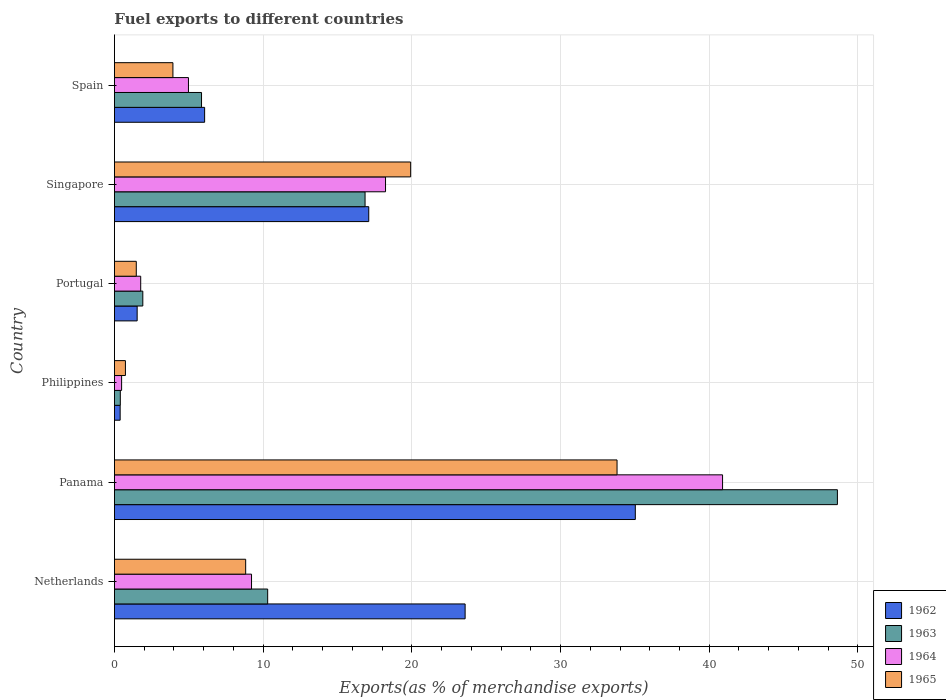How many different coloured bars are there?
Your response must be concise. 4. How many groups of bars are there?
Provide a short and direct response. 6. Are the number of bars on each tick of the Y-axis equal?
Your answer should be compact. Yes. How many bars are there on the 5th tick from the top?
Make the answer very short. 4. How many bars are there on the 4th tick from the bottom?
Ensure brevity in your answer.  4. In how many cases, is the number of bars for a given country not equal to the number of legend labels?
Offer a very short reply. 0. What is the percentage of exports to different countries in 1962 in Singapore?
Your answer should be compact. 17.1. Across all countries, what is the maximum percentage of exports to different countries in 1964?
Keep it short and to the point. 40.9. Across all countries, what is the minimum percentage of exports to different countries in 1963?
Provide a succinct answer. 0.4. In which country was the percentage of exports to different countries in 1964 maximum?
Your response must be concise. Panama. What is the total percentage of exports to different countries in 1964 in the graph?
Ensure brevity in your answer.  75.58. What is the difference between the percentage of exports to different countries in 1965 in Netherlands and that in Spain?
Your answer should be very brief. 4.89. What is the difference between the percentage of exports to different countries in 1965 in Portugal and the percentage of exports to different countries in 1963 in Philippines?
Provide a short and direct response. 1.07. What is the average percentage of exports to different countries in 1965 per country?
Offer a very short reply. 11.45. What is the difference between the percentage of exports to different countries in 1964 and percentage of exports to different countries in 1965 in Spain?
Provide a short and direct response. 1.04. In how many countries, is the percentage of exports to different countries in 1963 greater than 20 %?
Offer a very short reply. 1. What is the ratio of the percentage of exports to different countries in 1965 in Netherlands to that in Spain?
Ensure brevity in your answer.  2.24. Is the percentage of exports to different countries in 1962 in Panama less than that in Portugal?
Provide a succinct answer. No. What is the difference between the highest and the second highest percentage of exports to different countries in 1962?
Give a very brief answer. 11.45. What is the difference between the highest and the lowest percentage of exports to different countries in 1962?
Give a very brief answer. 34.64. In how many countries, is the percentage of exports to different countries in 1964 greater than the average percentage of exports to different countries in 1964 taken over all countries?
Provide a short and direct response. 2. Is the sum of the percentage of exports to different countries in 1965 in Panama and Singapore greater than the maximum percentage of exports to different countries in 1962 across all countries?
Keep it short and to the point. Yes. Is it the case that in every country, the sum of the percentage of exports to different countries in 1962 and percentage of exports to different countries in 1964 is greater than the sum of percentage of exports to different countries in 1965 and percentage of exports to different countries in 1963?
Ensure brevity in your answer.  No. What does the 1st bar from the top in Panama represents?
Keep it short and to the point. 1965. What does the 3rd bar from the bottom in Spain represents?
Provide a short and direct response. 1964. How many bars are there?
Your answer should be compact. 24. How many countries are there in the graph?
Keep it short and to the point. 6. Does the graph contain any zero values?
Keep it short and to the point. No. Does the graph contain grids?
Keep it short and to the point. Yes. Where does the legend appear in the graph?
Offer a terse response. Bottom right. How many legend labels are there?
Keep it short and to the point. 4. What is the title of the graph?
Give a very brief answer. Fuel exports to different countries. What is the label or title of the X-axis?
Offer a very short reply. Exports(as % of merchandise exports). What is the Exports(as % of merchandise exports) of 1962 in Netherlands?
Make the answer very short. 23.58. What is the Exports(as % of merchandise exports) of 1963 in Netherlands?
Ensure brevity in your answer.  10.31. What is the Exports(as % of merchandise exports) in 1964 in Netherlands?
Your answer should be very brief. 9.22. What is the Exports(as % of merchandise exports) in 1965 in Netherlands?
Offer a terse response. 8.83. What is the Exports(as % of merchandise exports) in 1962 in Panama?
Ensure brevity in your answer.  35.03. What is the Exports(as % of merchandise exports) in 1963 in Panama?
Your answer should be very brief. 48.62. What is the Exports(as % of merchandise exports) in 1964 in Panama?
Offer a terse response. 40.9. What is the Exports(as % of merchandise exports) of 1965 in Panama?
Make the answer very short. 33.8. What is the Exports(as % of merchandise exports) of 1962 in Philippines?
Provide a short and direct response. 0.38. What is the Exports(as % of merchandise exports) in 1963 in Philippines?
Your response must be concise. 0.4. What is the Exports(as % of merchandise exports) of 1964 in Philippines?
Keep it short and to the point. 0.48. What is the Exports(as % of merchandise exports) of 1965 in Philippines?
Give a very brief answer. 0.74. What is the Exports(as % of merchandise exports) of 1962 in Portugal?
Ensure brevity in your answer.  1.53. What is the Exports(as % of merchandise exports) of 1963 in Portugal?
Ensure brevity in your answer.  1.91. What is the Exports(as % of merchandise exports) in 1964 in Portugal?
Keep it short and to the point. 1.77. What is the Exports(as % of merchandise exports) in 1965 in Portugal?
Offer a terse response. 1.47. What is the Exports(as % of merchandise exports) in 1962 in Singapore?
Your answer should be compact. 17.1. What is the Exports(as % of merchandise exports) of 1963 in Singapore?
Provide a short and direct response. 16.85. What is the Exports(as % of merchandise exports) of 1964 in Singapore?
Make the answer very short. 18.23. What is the Exports(as % of merchandise exports) of 1965 in Singapore?
Your response must be concise. 19.92. What is the Exports(as % of merchandise exports) of 1962 in Spain?
Your response must be concise. 6.07. What is the Exports(as % of merchandise exports) in 1963 in Spain?
Your response must be concise. 5.86. What is the Exports(as % of merchandise exports) of 1964 in Spain?
Ensure brevity in your answer.  4.98. What is the Exports(as % of merchandise exports) in 1965 in Spain?
Make the answer very short. 3.93. Across all countries, what is the maximum Exports(as % of merchandise exports) in 1962?
Keep it short and to the point. 35.03. Across all countries, what is the maximum Exports(as % of merchandise exports) in 1963?
Provide a succinct answer. 48.62. Across all countries, what is the maximum Exports(as % of merchandise exports) of 1964?
Your answer should be very brief. 40.9. Across all countries, what is the maximum Exports(as % of merchandise exports) of 1965?
Provide a succinct answer. 33.8. Across all countries, what is the minimum Exports(as % of merchandise exports) of 1962?
Make the answer very short. 0.38. Across all countries, what is the minimum Exports(as % of merchandise exports) of 1963?
Ensure brevity in your answer.  0.4. Across all countries, what is the minimum Exports(as % of merchandise exports) of 1964?
Offer a terse response. 0.48. Across all countries, what is the minimum Exports(as % of merchandise exports) of 1965?
Your response must be concise. 0.74. What is the total Exports(as % of merchandise exports) in 1962 in the graph?
Offer a terse response. 83.7. What is the total Exports(as % of merchandise exports) in 1963 in the graph?
Ensure brevity in your answer.  83.94. What is the total Exports(as % of merchandise exports) in 1964 in the graph?
Your answer should be compact. 75.58. What is the total Exports(as % of merchandise exports) of 1965 in the graph?
Your answer should be very brief. 68.69. What is the difference between the Exports(as % of merchandise exports) in 1962 in Netherlands and that in Panama?
Offer a very short reply. -11.45. What is the difference between the Exports(as % of merchandise exports) in 1963 in Netherlands and that in Panama?
Ensure brevity in your answer.  -38.32. What is the difference between the Exports(as % of merchandise exports) of 1964 in Netherlands and that in Panama?
Ensure brevity in your answer.  -31.68. What is the difference between the Exports(as % of merchandise exports) in 1965 in Netherlands and that in Panama?
Provide a succinct answer. -24.98. What is the difference between the Exports(as % of merchandise exports) of 1962 in Netherlands and that in Philippines?
Keep it short and to the point. 23.2. What is the difference between the Exports(as % of merchandise exports) in 1963 in Netherlands and that in Philippines?
Make the answer very short. 9.91. What is the difference between the Exports(as % of merchandise exports) of 1964 in Netherlands and that in Philippines?
Your answer should be very brief. 8.74. What is the difference between the Exports(as % of merchandise exports) of 1965 in Netherlands and that in Philippines?
Your answer should be compact. 8.09. What is the difference between the Exports(as % of merchandise exports) in 1962 in Netherlands and that in Portugal?
Your answer should be very brief. 22.06. What is the difference between the Exports(as % of merchandise exports) in 1963 in Netherlands and that in Portugal?
Offer a very short reply. 8.4. What is the difference between the Exports(as % of merchandise exports) in 1964 in Netherlands and that in Portugal?
Your answer should be very brief. 7.45. What is the difference between the Exports(as % of merchandise exports) in 1965 in Netherlands and that in Portugal?
Provide a short and direct response. 7.36. What is the difference between the Exports(as % of merchandise exports) in 1962 in Netherlands and that in Singapore?
Keep it short and to the point. 6.48. What is the difference between the Exports(as % of merchandise exports) of 1963 in Netherlands and that in Singapore?
Offer a very short reply. -6.55. What is the difference between the Exports(as % of merchandise exports) in 1964 in Netherlands and that in Singapore?
Your answer should be compact. -9.01. What is the difference between the Exports(as % of merchandise exports) in 1965 in Netherlands and that in Singapore?
Give a very brief answer. -11.1. What is the difference between the Exports(as % of merchandise exports) of 1962 in Netherlands and that in Spain?
Offer a very short reply. 17.52. What is the difference between the Exports(as % of merchandise exports) in 1963 in Netherlands and that in Spain?
Provide a short and direct response. 4.45. What is the difference between the Exports(as % of merchandise exports) in 1964 in Netherlands and that in Spain?
Your answer should be very brief. 4.24. What is the difference between the Exports(as % of merchandise exports) of 1965 in Netherlands and that in Spain?
Offer a terse response. 4.89. What is the difference between the Exports(as % of merchandise exports) of 1962 in Panama and that in Philippines?
Provide a short and direct response. 34.65. What is the difference between the Exports(as % of merchandise exports) of 1963 in Panama and that in Philippines?
Make the answer very short. 48.22. What is the difference between the Exports(as % of merchandise exports) of 1964 in Panama and that in Philippines?
Offer a terse response. 40.41. What is the difference between the Exports(as % of merchandise exports) of 1965 in Panama and that in Philippines?
Your response must be concise. 33.06. What is the difference between the Exports(as % of merchandise exports) in 1962 in Panama and that in Portugal?
Offer a terse response. 33.5. What is the difference between the Exports(as % of merchandise exports) in 1963 in Panama and that in Portugal?
Keep it short and to the point. 46.71. What is the difference between the Exports(as % of merchandise exports) in 1964 in Panama and that in Portugal?
Make the answer very short. 39.13. What is the difference between the Exports(as % of merchandise exports) in 1965 in Panama and that in Portugal?
Offer a terse response. 32.33. What is the difference between the Exports(as % of merchandise exports) in 1962 in Panama and that in Singapore?
Your answer should be compact. 17.93. What is the difference between the Exports(as % of merchandise exports) of 1963 in Panama and that in Singapore?
Keep it short and to the point. 31.77. What is the difference between the Exports(as % of merchandise exports) of 1964 in Panama and that in Singapore?
Give a very brief answer. 22.67. What is the difference between the Exports(as % of merchandise exports) of 1965 in Panama and that in Singapore?
Give a very brief answer. 13.88. What is the difference between the Exports(as % of merchandise exports) of 1962 in Panama and that in Spain?
Ensure brevity in your answer.  28.96. What is the difference between the Exports(as % of merchandise exports) in 1963 in Panama and that in Spain?
Provide a short and direct response. 42.76. What is the difference between the Exports(as % of merchandise exports) of 1964 in Panama and that in Spain?
Make the answer very short. 35.92. What is the difference between the Exports(as % of merchandise exports) of 1965 in Panama and that in Spain?
Give a very brief answer. 29.87. What is the difference between the Exports(as % of merchandise exports) in 1962 in Philippines and that in Portugal?
Your answer should be compact. -1.14. What is the difference between the Exports(as % of merchandise exports) in 1963 in Philippines and that in Portugal?
Make the answer very short. -1.51. What is the difference between the Exports(as % of merchandise exports) in 1964 in Philippines and that in Portugal?
Keep it short and to the point. -1.28. What is the difference between the Exports(as % of merchandise exports) of 1965 in Philippines and that in Portugal?
Keep it short and to the point. -0.73. What is the difference between the Exports(as % of merchandise exports) of 1962 in Philippines and that in Singapore?
Keep it short and to the point. -16.72. What is the difference between the Exports(as % of merchandise exports) in 1963 in Philippines and that in Singapore?
Provide a short and direct response. -16.46. What is the difference between the Exports(as % of merchandise exports) of 1964 in Philippines and that in Singapore?
Ensure brevity in your answer.  -17.75. What is the difference between the Exports(as % of merchandise exports) in 1965 in Philippines and that in Singapore?
Ensure brevity in your answer.  -19.18. What is the difference between the Exports(as % of merchandise exports) in 1962 in Philippines and that in Spain?
Your response must be concise. -5.68. What is the difference between the Exports(as % of merchandise exports) of 1963 in Philippines and that in Spain?
Offer a very short reply. -5.46. What is the difference between the Exports(as % of merchandise exports) in 1964 in Philippines and that in Spain?
Give a very brief answer. -4.49. What is the difference between the Exports(as % of merchandise exports) of 1965 in Philippines and that in Spain?
Provide a short and direct response. -3.19. What is the difference between the Exports(as % of merchandise exports) in 1962 in Portugal and that in Singapore?
Offer a terse response. -15.58. What is the difference between the Exports(as % of merchandise exports) of 1963 in Portugal and that in Singapore?
Keep it short and to the point. -14.95. What is the difference between the Exports(as % of merchandise exports) of 1964 in Portugal and that in Singapore?
Provide a succinct answer. -16.47. What is the difference between the Exports(as % of merchandise exports) of 1965 in Portugal and that in Singapore?
Keep it short and to the point. -18.45. What is the difference between the Exports(as % of merchandise exports) in 1962 in Portugal and that in Spain?
Offer a very short reply. -4.54. What is the difference between the Exports(as % of merchandise exports) in 1963 in Portugal and that in Spain?
Offer a terse response. -3.95. What is the difference between the Exports(as % of merchandise exports) in 1964 in Portugal and that in Spain?
Ensure brevity in your answer.  -3.21. What is the difference between the Exports(as % of merchandise exports) in 1965 in Portugal and that in Spain?
Offer a terse response. -2.46. What is the difference between the Exports(as % of merchandise exports) in 1962 in Singapore and that in Spain?
Make the answer very short. 11.04. What is the difference between the Exports(as % of merchandise exports) in 1963 in Singapore and that in Spain?
Offer a very short reply. 11. What is the difference between the Exports(as % of merchandise exports) of 1964 in Singapore and that in Spain?
Provide a short and direct response. 13.25. What is the difference between the Exports(as % of merchandise exports) of 1965 in Singapore and that in Spain?
Provide a short and direct response. 15.99. What is the difference between the Exports(as % of merchandise exports) of 1962 in Netherlands and the Exports(as % of merchandise exports) of 1963 in Panama?
Make the answer very short. -25.04. What is the difference between the Exports(as % of merchandise exports) of 1962 in Netherlands and the Exports(as % of merchandise exports) of 1964 in Panama?
Ensure brevity in your answer.  -17.31. What is the difference between the Exports(as % of merchandise exports) of 1962 in Netherlands and the Exports(as % of merchandise exports) of 1965 in Panama?
Your answer should be compact. -10.22. What is the difference between the Exports(as % of merchandise exports) in 1963 in Netherlands and the Exports(as % of merchandise exports) in 1964 in Panama?
Make the answer very short. -30.59. What is the difference between the Exports(as % of merchandise exports) in 1963 in Netherlands and the Exports(as % of merchandise exports) in 1965 in Panama?
Provide a short and direct response. -23.5. What is the difference between the Exports(as % of merchandise exports) of 1964 in Netherlands and the Exports(as % of merchandise exports) of 1965 in Panama?
Your answer should be very brief. -24.58. What is the difference between the Exports(as % of merchandise exports) of 1962 in Netherlands and the Exports(as % of merchandise exports) of 1963 in Philippines?
Your response must be concise. 23.19. What is the difference between the Exports(as % of merchandise exports) in 1962 in Netherlands and the Exports(as % of merchandise exports) in 1964 in Philippines?
Provide a short and direct response. 23.1. What is the difference between the Exports(as % of merchandise exports) in 1962 in Netherlands and the Exports(as % of merchandise exports) in 1965 in Philippines?
Your answer should be compact. 22.84. What is the difference between the Exports(as % of merchandise exports) in 1963 in Netherlands and the Exports(as % of merchandise exports) in 1964 in Philippines?
Your answer should be very brief. 9.82. What is the difference between the Exports(as % of merchandise exports) of 1963 in Netherlands and the Exports(as % of merchandise exports) of 1965 in Philippines?
Offer a terse response. 9.57. What is the difference between the Exports(as % of merchandise exports) in 1964 in Netherlands and the Exports(as % of merchandise exports) in 1965 in Philippines?
Offer a very short reply. 8.48. What is the difference between the Exports(as % of merchandise exports) of 1962 in Netherlands and the Exports(as % of merchandise exports) of 1963 in Portugal?
Give a very brief answer. 21.68. What is the difference between the Exports(as % of merchandise exports) in 1962 in Netherlands and the Exports(as % of merchandise exports) in 1964 in Portugal?
Provide a succinct answer. 21.82. What is the difference between the Exports(as % of merchandise exports) in 1962 in Netherlands and the Exports(as % of merchandise exports) in 1965 in Portugal?
Provide a short and direct response. 22.11. What is the difference between the Exports(as % of merchandise exports) of 1963 in Netherlands and the Exports(as % of merchandise exports) of 1964 in Portugal?
Ensure brevity in your answer.  8.54. What is the difference between the Exports(as % of merchandise exports) of 1963 in Netherlands and the Exports(as % of merchandise exports) of 1965 in Portugal?
Your response must be concise. 8.84. What is the difference between the Exports(as % of merchandise exports) in 1964 in Netherlands and the Exports(as % of merchandise exports) in 1965 in Portugal?
Your answer should be compact. 7.75. What is the difference between the Exports(as % of merchandise exports) in 1962 in Netherlands and the Exports(as % of merchandise exports) in 1963 in Singapore?
Offer a very short reply. 6.73. What is the difference between the Exports(as % of merchandise exports) of 1962 in Netherlands and the Exports(as % of merchandise exports) of 1964 in Singapore?
Make the answer very short. 5.35. What is the difference between the Exports(as % of merchandise exports) of 1962 in Netherlands and the Exports(as % of merchandise exports) of 1965 in Singapore?
Give a very brief answer. 3.66. What is the difference between the Exports(as % of merchandise exports) of 1963 in Netherlands and the Exports(as % of merchandise exports) of 1964 in Singapore?
Make the answer very short. -7.93. What is the difference between the Exports(as % of merchandise exports) in 1963 in Netherlands and the Exports(as % of merchandise exports) in 1965 in Singapore?
Make the answer very short. -9.62. What is the difference between the Exports(as % of merchandise exports) of 1964 in Netherlands and the Exports(as % of merchandise exports) of 1965 in Singapore?
Your answer should be very brief. -10.7. What is the difference between the Exports(as % of merchandise exports) in 1962 in Netherlands and the Exports(as % of merchandise exports) in 1963 in Spain?
Keep it short and to the point. 17.73. What is the difference between the Exports(as % of merchandise exports) of 1962 in Netherlands and the Exports(as % of merchandise exports) of 1964 in Spain?
Ensure brevity in your answer.  18.61. What is the difference between the Exports(as % of merchandise exports) in 1962 in Netherlands and the Exports(as % of merchandise exports) in 1965 in Spain?
Your answer should be very brief. 19.65. What is the difference between the Exports(as % of merchandise exports) of 1963 in Netherlands and the Exports(as % of merchandise exports) of 1964 in Spain?
Your answer should be very brief. 5.33. What is the difference between the Exports(as % of merchandise exports) of 1963 in Netherlands and the Exports(as % of merchandise exports) of 1965 in Spain?
Your answer should be compact. 6.37. What is the difference between the Exports(as % of merchandise exports) in 1964 in Netherlands and the Exports(as % of merchandise exports) in 1965 in Spain?
Offer a very short reply. 5.29. What is the difference between the Exports(as % of merchandise exports) of 1962 in Panama and the Exports(as % of merchandise exports) of 1963 in Philippines?
Offer a terse response. 34.63. What is the difference between the Exports(as % of merchandise exports) of 1962 in Panama and the Exports(as % of merchandise exports) of 1964 in Philippines?
Keep it short and to the point. 34.55. What is the difference between the Exports(as % of merchandise exports) in 1962 in Panama and the Exports(as % of merchandise exports) in 1965 in Philippines?
Your answer should be very brief. 34.29. What is the difference between the Exports(as % of merchandise exports) in 1963 in Panama and the Exports(as % of merchandise exports) in 1964 in Philippines?
Make the answer very short. 48.14. What is the difference between the Exports(as % of merchandise exports) in 1963 in Panama and the Exports(as % of merchandise exports) in 1965 in Philippines?
Make the answer very short. 47.88. What is the difference between the Exports(as % of merchandise exports) of 1964 in Panama and the Exports(as % of merchandise exports) of 1965 in Philippines?
Make the answer very short. 40.16. What is the difference between the Exports(as % of merchandise exports) in 1962 in Panama and the Exports(as % of merchandise exports) in 1963 in Portugal?
Give a very brief answer. 33.12. What is the difference between the Exports(as % of merchandise exports) in 1962 in Panama and the Exports(as % of merchandise exports) in 1964 in Portugal?
Your response must be concise. 33.26. What is the difference between the Exports(as % of merchandise exports) in 1962 in Panama and the Exports(as % of merchandise exports) in 1965 in Portugal?
Make the answer very short. 33.56. What is the difference between the Exports(as % of merchandise exports) in 1963 in Panama and the Exports(as % of merchandise exports) in 1964 in Portugal?
Offer a very short reply. 46.85. What is the difference between the Exports(as % of merchandise exports) in 1963 in Panama and the Exports(as % of merchandise exports) in 1965 in Portugal?
Keep it short and to the point. 47.15. What is the difference between the Exports(as % of merchandise exports) in 1964 in Panama and the Exports(as % of merchandise exports) in 1965 in Portugal?
Provide a short and direct response. 39.43. What is the difference between the Exports(as % of merchandise exports) in 1962 in Panama and the Exports(as % of merchandise exports) in 1963 in Singapore?
Your response must be concise. 18.18. What is the difference between the Exports(as % of merchandise exports) of 1962 in Panama and the Exports(as % of merchandise exports) of 1964 in Singapore?
Your response must be concise. 16.8. What is the difference between the Exports(as % of merchandise exports) in 1962 in Panama and the Exports(as % of merchandise exports) in 1965 in Singapore?
Provide a short and direct response. 15.11. What is the difference between the Exports(as % of merchandise exports) of 1963 in Panama and the Exports(as % of merchandise exports) of 1964 in Singapore?
Offer a terse response. 30.39. What is the difference between the Exports(as % of merchandise exports) of 1963 in Panama and the Exports(as % of merchandise exports) of 1965 in Singapore?
Ensure brevity in your answer.  28.7. What is the difference between the Exports(as % of merchandise exports) in 1964 in Panama and the Exports(as % of merchandise exports) in 1965 in Singapore?
Your answer should be compact. 20.98. What is the difference between the Exports(as % of merchandise exports) in 1962 in Panama and the Exports(as % of merchandise exports) in 1963 in Spain?
Provide a short and direct response. 29.17. What is the difference between the Exports(as % of merchandise exports) in 1962 in Panama and the Exports(as % of merchandise exports) in 1964 in Spain?
Make the answer very short. 30.05. What is the difference between the Exports(as % of merchandise exports) in 1962 in Panama and the Exports(as % of merchandise exports) in 1965 in Spain?
Give a very brief answer. 31.1. What is the difference between the Exports(as % of merchandise exports) of 1963 in Panama and the Exports(as % of merchandise exports) of 1964 in Spain?
Ensure brevity in your answer.  43.64. What is the difference between the Exports(as % of merchandise exports) of 1963 in Panama and the Exports(as % of merchandise exports) of 1965 in Spain?
Ensure brevity in your answer.  44.69. What is the difference between the Exports(as % of merchandise exports) of 1964 in Panama and the Exports(as % of merchandise exports) of 1965 in Spain?
Make the answer very short. 36.96. What is the difference between the Exports(as % of merchandise exports) of 1962 in Philippines and the Exports(as % of merchandise exports) of 1963 in Portugal?
Your answer should be compact. -1.52. What is the difference between the Exports(as % of merchandise exports) of 1962 in Philippines and the Exports(as % of merchandise exports) of 1964 in Portugal?
Make the answer very short. -1.38. What is the difference between the Exports(as % of merchandise exports) of 1962 in Philippines and the Exports(as % of merchandise exports) of 1965 in Portugal?
Your answer should be compact. -1.08. What is the difference between the Exports(as % of merchandise exports) in 1963 in Philippines and the Exports(as % of merchandise exports) in 1964 in Portugal?
Provide a short and direct response. -1.37. What is the difference between the Exports(as % of merchandise exports) of 1963 in Philippines and the Exports(as % of merchandise exports) of 1965 in Portugal?
Ensure brevity in your answer.  -1.07. What is the difference between the Exports(as % of merchandise exports) of 1964 in Philippines and the Exports(as % of merchandise exports) of 1965 in Portugal?
Provide a succinct answer. -0.99. What is the difference between the Exports(as % of merchandise exports) of 1962 in Philippines and the Exports(as % of merchandise exports) of 1963 in Singapore?
Your response must be concise. -16.47. What is the difference between the Exports(as % of merchandise exports) of 1962 in Philippines and the Exports(as % of merchandise exports) of 1964 in Singapore?
Ensure brevity in your answer.  -17.85. What is the difference between the Exports(as % of merchandise exports) in 1962 in Philippines and the Exports(as % of merchandise exports) in 1965 in Singapore?
Your answer should be compact. -19.54. What is the difference between the Exports(as % of merchandise exports) in 1963 in Philippines and the Exports(as % of merchandise exports) in 1964 in Singapore?
Your answer should be compact. -17.84. What is the difference between the Exports(as % of merchandise exports) of 1963 in Philippines and the Exports(as % of merchandise exports) of 1965 in Singapore?
Offer a very short reply. -19.53. What is the difference between the Exports(as % of merchandise exports) of 1964 in Philippines and the Exports(as % of merchandise exports) of 1965 in Singapore?
Offer a terse response. -19.44. What is the difference between the Exports(as % of merchandise exports) of 1962 in Philippines and the Exports(as % of merchandise exports) of 1963 in Spain?
Make the answer very short. -5.47. What is the difference between the Exports(as % of merchandise exports) in 1962 in Philippines and the Exports(as % of merchandise exports) in 1964 in Spain?
Make the answer very short. -4.59. What is the difference between the Exports(as % of merchandise exports) in 1962 in Philippines and the Exports(as % of merchandise exports) in 1965 in Spain?
Provide a succinct answer. -3.55. What is the difference between the Exports(as % of merchandise exports) in 1963 in Philippines and the Exports(as % of merchandise exports) in 1964 in Spain?
Your answer should be very brief. -4.58. What is the difference between the Exports(as % of merchandise exports) of 1963 in Philippines and the Exports(as % of merchandise exports) of 1965 in Spain?
Make the answer very short. -3.54. What is the difference between the Exports(as % of merchandise exports) in 1964 in Philippines and the Exports(as % of merchandise exports) in 1965 in Spain?
Provide a short and direct response. -3.45. What is the difference between the Exports(as % of merchandise exports) of 1962 in Portugal and the Exports(as % of merchandise exports) of 1963 in Singapore?
Offer a terse response. -15.33. What is the difference between the Exports(as % of merchandise exports) in 1962 in Portugal and the Exports(as % of merchandise exports) in 1964 in Singapore?
Make the answer very short. -16.7. What is the difference between the Exports(as % of merchandise exports) in 1962 in Portugal and the Exports(as % of merchandise exports) in 1965 in Singapore?
Provide a succinct answer. -18.39. What is the difference between the Exports(as % of merchandise exports) of 1963 in Portugal and the Exports(as % of merchandise exports) of 1964 in Singapore?
Provide a succinct answer. -16.32. What is the difference between the Exports(as % of merchandise exports) of 1963 in Portugal and the Exports(as % of merchandise exports) of 1965 in Singapore?
Your answer should be very brief. -18.01. What is the difference between the Exports(as % of merchandise exports) of 1964 in Portugal and the Exports(as % of merchandise exports) of 1965 in Singapore?
Keep it short and to the point. -18.16. What is the difference between the Exports(as % of merchandise exports) in 1962 in Portugal and the Exports(as % of merchandise exports) in 1963 in Spain?
Keep it short and to the point. -4.33. What is the difference between the Exports(as % of merchandise exports) of 1962 in Portugal and the Exports(as % of merchandise exports) of 1964 in Spain?
Your response must be concise. -3.45. What is the difference between the Exports(as % of merchandise exports) in 1962 in Portugal and the Exports(as % of merchandise exports) in 1965 in Spain?
Provide a succinct answer. -2.41. What is the difference between the Exports(as % of merchandise exports) of 1963 in Portugal and the Exports(as % of merchandise exports) of 1964 in Spain?
Your answer should be very brief. -3.07. What is the difference between the Exports(as % of merchandise exports) of 1963 in Portugal and the Exports(as % of merchandise exports) of 1965 in Spain?
Offer a very short reply. -2.03. What is the difference between the Exports(as % of merchandise exports) of 1964 in Portugal and the Exports(as % of merchandise exports) of 1965 in Spain?
Your answer should be very brief. -2.17. What is the difference between the Exports(as % of merchandise exports) in 1962 in Singapore and the Exports(as % of merchandise exports) in 1963 in Spain?
Keep it short and to the point. 11.25. What is the difference between the Exports(as % of merchandise exports) in 1962 in Singapore and the Exports(as % of merchandise exports) in 1964 in Spain?
Give a very brief answer. 12.13. What is the difference between the Exports(as % of merchandise exports) of 1962 in Singapore and the Exports(as % of merchandise exports) of 1965 in Spain?
Provide a short and direct response. 13.17. What is the difference between the Exports(as % of merchandise exports) of 1963 in Singapore and the Exports(as % of merchandise exports) of 1964 in Spain?
Your answer should be very brief. 11.88. What is the difference between the Exports(as % of merchandise exports) of 1963 in Singapore and the Exports(as % of merchandise exports) of 1965 in Spain?
Your response must be concise. 12.92. What is the difference between the Exports(as % of merchandise exports) in 1964 in Singapore and the Exports(as % of merchandise exports) in 1965 in Spain?
Give a very brief answer. 14.3. What is the average Exports(as % of merchandise exports) of 1962 per country?
Offer a very short reply. 13.95. What is the average Exports(as % of merchandise exports) in 1963 per country?
Keep it short and to the point. 13.99. What is the average Exports(as % of merchandise exports) of 1964 per country?
Your response must be concise. 12.6. What is the average Exports(as % of merchandise exports) in 1965 per country?
Ensure brevity in your answer.  11.45. What is the difference between the Exports(as % of merchandise exports) in 1962 and Exports(as % of merchandise exports) in 1963 in Netherlands?
Your answer should be very brief. 13.28. What is the difference between the Exports(as % of merchandise exports) in 1962 and Exports(as % of merchandise exports) in 1964 in Netherlands?
Your answer should be compact. 14.36. What is the difference between the Exports(as % of merchandise exports) in 1962 and Exports(as % of merchandise exports) in 1965 in Netherlands?
Give a very brief answer. 14.76. What is the difference between the Exports(as % of merchandise exports) of 1963 and Exports(as % of merchandise exports) of 1964 in Netherlands?
Provide a short and direct response. 1.09. What is the difference between the Exports(as % of merchandise exports) in 1963 and Exports(as % of merchandise exports) in 1965 in Netherlands?
Provide a short and direct response. 1.48. What is the difference between the Exports(as % of merchandise exports) of 1964 and Exports(as % of merchandise exports) of 1965 in Netherlands?
Make the answer very short. 0.39. What is the difference between the Exports(as % of merchandise exports) of 1962 and Exports(as % of merchandise exports) of 1963 in Panama?
Provide a short and direct response. -13.59. What is the difference between the Exports(as % of merchandise exports) of 1962 and Exports(as % of merchandise exports) of 1964 in Panama?
Offer a very short reply. -5.87. What is the difference between the Exports(as % of merchandise exports) in 1962 and Exports(as % of merchandise exports) in 1965 in Panama?
Provide a succinct answer. 1.23. What is the difference between the Exports(as % of merchandise exports) in 1963 and Exports(as % of merchandise exports) in 1964 in Panama?
Offer a terse response. 7.72. What is the difference between the Exports(as % of merchandise exports) of 1963 and Exports(as % of merchandise exports) of 1965 in Panama?
Provide a succinct answer. 14.82. What is the difference between the Exports(as % of merchandise exports) of 1964 and Exports(as % of merchandise exports) of 1965 in Panama?
Ensure brevity in your answer.  7.1. What is the difference between the Exports(as % of merchandise exports) in 1962 and Exports(as % of merchandise exports) in 1963 in Philippines?
Your response must be concise. -0.01. What is the difference between the Exports(as % of merchandise exports) of 1962 and Exports(as % of merchandise exports) of 1964 in Philippines?
Ensure brevity in your answer.  -0.1. What is the difference between the Exports(as % of merchandise exports) of 1962 and Exports(as % of merchandise exports) of 1965 in Philippines?
Your answer should be compact. -0.35. What is the difference between the Exports(as % of merchandise exports) in 1963 and Exports(as % of merchandise exports) in 1964 in Philippines?
Provide a succinct answer. -0.09. What is the difference between the Exports(as % of merchandise exports) of 1963 and Exports(as % of merchandise exports) of 1965 in Philippines?
Keep it short and to the point. -0.34. What is the difference between the Exports(as % of merchandise exports) in 1964 and Exports(as % of merchandise exports) in 1965 in Philippines?
Offer a very short reply. -0.26. What is the difference between the Exports(as % of merchandise exports) of 1962 and Exports(as % of merchandise exports) of 1963 in Portugal?
Your answer should be very brief. -0.38. What is the difference between the Exports(as % of merchandise exports) of 1962 and Exports(as % of merchandise exports) of 1964 in Portugal?
Give a very brief answer. -0.24. What is the difference between the Exports(as % of merchandise exports) in 1962 and Exports(as % of merchandise exports) in 1965 in Portugal?
Make the answer very short. 0.06. What is the difference between the Exports(as % of merchandise exports) of 1963 and Exports(as % of merchandise exports) of 1964 in Portugal?
Ensure brevity in your answer.  0.14. What is the difference between the Exports(as % of merchandise exports) in 1963 and Exports(as % of merchandise exports) in 1965 in Portugal?
Ensure brevity in your answer.  0.44. What is the difference between the Exports(as % of merchandise exports) of 1964 and Exports(as % of merchandise exports) of 1965 in Portugal?
Give a very brief answer. 0.3. What is the difference between the Exports(as % of merchandise exports) of 1962 and Exports(as % of merchandise exports) of 1963 in Singapore?
Your answer should be very brief. 0.25. What is the difference between the Exports(as % of merchandise exports) in 1962 and Exports(as % of merchandise exports) in 1964 in Singapore?
Offer a very short reply. -1.13. What is the difference between the Exports(as % of merchandise exports) of 1962 and Exports(as % of merchandise exports) of 1965 in Singapore?
Offer a terse response. -2.82. What is the difference between the Exports(as % of merchandise exports) in 1963 and Exports(as % of merchandise exports) in 1964 in Singapore?
Your answer should be compact. -1.38. What is the difference between the Exports(as % of merchandise exports) in 1963 and Exports(as % of merchandise exports) in 1965 in Singapore?
Your answer should be very brief. -3.07. What is the difference between the Exports(as % of merchandise exports) in 1964 and Exports(as % of merchandise exports) in 1965 in Singapore?
Provide a succinct answer. -1.69. What is the difference between the Exports(as % of merchandise exports) in 1962 and Exports(as % of merchandise exports) in 1963 in Spain?
Provide a succinct answer. 0.21. What is the difference between the Exports(as % of merchandise exports) in 1962 and Exports(as % of merchandise exports) in 1964 in Spain?
Give a very brief answer. 1.09. What is the difference between the Exports(as % of merchandise exports) in 1962 and Exports(as % of merchandise exports) in 1965 in Spain?
Offer a terse response. 2.13. What is the difference between the Exports(as % of merchandise exports) in 1963 and Exports(as % of merchandise exports) in 1964 in Spain?
Provide a succinct answer. 0.88. What is the difference between the Exports(as % of merchandise exports) in 1963 and Exports(as % of merchandise exports) in 1965 in Spain?
Offer a terse response. 1.92. What is the difference between the Exports(as % of merchandise exports) in 1964 and Exports(as % of merchandise exports) in 1965 in Spain?
Offer a very short reply. 1.04. What is the ratio of the Exports(as % of merchandise exports) in 1962 in Netherlands to that in Panama?
Provide a succinct answer. 0.67. What is the ratio of the Exports(as % of merchandise exports) of 1963 in Netherlands to that in Panama?
Your answer should be compact. 0.21. What is the ratio of the Exports(as % of merchandise exports) in 1964 in Netherlands to that in Panama?
Your answer should be compact. 0.23. What is the ratio of the Exports(as % of merchandise exports) of 1965 in Netherlands to that in Panama?
Your answer should be very brief. 0.26. What is the ratio of the Exports(as % of merchandise exports) of 1962 in Netherlands to that in Philippines?
Offer a very short reply. 61.27. What is the ratio of the Exports(as % of merchandise exports) of 1963 in Netherlands to that in Philippines?
Your answer should be compact. 26.03. What is the ratio of the Exports(as % of merchandise exports) in 1964 in Netherlands to that in Philippines?
Give a very brief answer. 19.07. What is the ratio of the Exports(as % of merchandise exports) in 1965 in Netherlands to that in Philippines?
Offer a very short reply. 11.93. What is the ratio of the Exports(as % of merchandise exports) in 1962 in Netherlands to that in Portugal?
Provide a succinct answer. 15.43. What is the ratio of the Exports(as % of merchandise exports) in 1963 in Netherlands to that in Portugal?
Make the answer very short. 5.4. What is the ratio of the Exports(as % of merchandise exports) of 1964 in Netherlands to that in Portugal?
Keep it short and to the point. 5.22. What is the ratio of the Exports(as % of merchandise exports) of 1965 in Netherlands to that in Portugal?
Offer a terse response. 6.01. What is the ratio of the Exports(as % of merchandise exports) of 1962 in Netherlands to that in Singapore?
Offer a terse response. 1.38. What is the ratio of the Exports(as % of merchandise exports) in 1963 in Netherlands to that in Singapore?
Give a very brief answer. 0.61. What is the ratio of the Exports(as % of merchandise exports) in 1964 in Netherlands to that in Singapore?
Offer a very short reply. 0.51. What is the ratio of the Exports(as % of merchandise exports) of 1965 in Netherlands to that in Singapore?
Ensure brevity in your answer.  0.44. What is the ratio of the Exports(as % of merchandise exports) in 1962 in Netherlands to that in Spain?
Make the answer very short. 3.89. What is the ratio of the Exports(as % of merchandise exports) of 1963 in Netherlands to that in Spain?
Provide a succinct answer. 1.76. What is the ratio of the Exports(as % of merchandise exports) of 1964 in Netherlands to that in Spain?
Your response must be concise. 1.85. What is the ratio of the Exports(as % of merchandise exports) in 1965 in Netherlands to that in Spain?
Give a very brief answer. 2.24. What is the ratio of the Exports(as % of merchandise exports) in 1962 in Panama to that in Philippines?
Provide a short and direct response. 91.01. What is the ratio of the Exports(as % of merchandise exports) in 1963 in Panama to that in Philippines?
Offer a very short reply. 122.82. What is the ratio of the Exports(as % of merchandise exports) in 1964 in Panama to that in Philippines?
Your answer should be very brief. 84.6. What is the ratio of the Exports(as % of merchandise exports) of 1965 in Panama to that in Philippines?
Provide a succinct answer. 45.69. What is the ratio of the Exports(as % of merchandise exports) in 1962 in Panama to that in Portugal?
Your answer should be compact. 22.92. What is the ratio of the Exports(as % of merchandise exports) of 1963 in Panama to that in Portugal?
Ensure brevity in your answer.  25.47. What is the ratio of the Exports(as % of merchandise exports) in 1964 in Panama to that in Portugal?
Ensure brevity in your answer.  23.15. What is the ratio of the Exports(as % of merchandise exports) of 1965 in Panama to that in Portugal?
Your answer should be compact. 23. What is the ratio of the Exports(as % of merchandise exports) of 1962 in Panama to that in Singapore?
Your response must be concise. 2.05. What is the ratio of the Exports(as % of merchandise exports) in 1963 in Panama to that in Singapore?
Provide a short and direct response. 2.88. What is the ratio of the Exports(as % of merchandise exports) in 1964 in Panama to that in Singapore?
Give a very brief answer. 2.24. What is the ratio of the Exports(as % of merchandise exports) in 1965 in Panama to that in Singapore?
Your response must be concise. 1.7. What is the ratio of the Exports(as % of merchandise exports) of 1962 in Panama to that in Spain?
Your answer should be compact. 5.77. What is the ratio of the Exports(as % of merchandise exports) of 1963 in Panama to that in Spain?
Give a very brief answer. 8.3. What is the ratio of the Exports(as % of merchandise exports) in 1964 in Panama to that in Spain?
Ensure brevity in your answer.  8.22. What is the ratio of the Exports(as % of merchandise exports) in 1965 in Panama to that in Spain?
Keep it short and to the point. 8.59. What is the ratio of the Exports(as % of merchandise exports) of 1962 in Philippines to that in Portugal?
Your answer should be very brief. 0.25. What is the ratio of the Exports(as % of merchandise exports) of 1963 in Philippines to that in Portugal?
Your answer should be compact. 0.21. What is the ratio of the Exports(as % of merchandise exports) of 1964 in Philippines to that in Portugal?
Provide a succinct answer. 0.27. What is the ratio of the Exports(as % of merchandise exports) in 1965 in Philippines to that in Portugal?
Give a very brief answer. 0.5. What is the ratio of the Exports(as % of merchandise exports) in 1962 in Philippines to that in Singapore?
Your answer should be compact. 0.02. What is the ratio of the Exports(as % of merchandise exports) of 1963 in Philippines to that in Singapore?
Offer a very short reply. 0.02. What is the ratio of the Exports(as % of merchandise exports) in 1964 in Philippines to that in Singapore?
Ensure brevity in your answer.  0.03. What is the ratio of the Exports(as % of merchandise exports) in 1965 in Philippines to that in Singapore?
Make the answer very short. 0.04. What is the ratio of the Exports(as % of merchandise exports) in 1962 in Philippines to that in Spain?
Ensure brevity in your answer.  0.06. What is the ratio of the Exports(as % of merchandise exports) in 1963 in Philippines to that in Spain?
Your answer should be very brief. 0.07. What is the ratio of the Exports(as % of merchandise exports) in 1964 in Philippines to that in Spain?
Offer a very short reply. 0.1. What is the ratio of the Exports(as % of merchandise exports) in 1965 in Philippines to that in Spain?
Offer a terse response. 0.19. What is the ratio of the Exports(as % of merchandise exports) in 1962 in Portugal to that in Singapore?
Provide a succinct answer. 0.09. What is the ratio of the Exports(as % of merchandise exports) of 1963 in Portugal to that in Singapore?
Your answer should be very brief. 0.11. What is the ratio of the Exports(as % of merchandise exports) in 1964 in Portugal to that in Singapore?
Give a very brief answer. 0.1. What is the ratio of the Exports(as % of merchandise exports) in 1965 in Portugal to that in Singapore?
Provide a succinct answer. 0.07. What is the ratio of the Exports(as % of merchandise exports) in 1962 in Portugal to that in Spain?
Offer a very short reply. 0.25. What is the ratio of the Exports(as % of merchandise exports) of 1963 in Portugal to that in Spain?
Provide a short and direct response. 0.33. What is the ratio of the Exports(as % of merchandise exports) in 1964 in Portugal to that in Spain?
Your response must be concise. 0.35. What is the ratio of the Exports(as % of merchandise exports) of 1965 in Portugal to that in Spain?
Ensure brevity in your answer.  0.37. What is the ratio of the Exports(as % of merchandise exports) in 1962 in Singapore to that in Spain?
Your response must be concise. 2.82. What is the ratio of the Exports(as % of merchandise exports) in 1963 in Singapore to that in Spain?
Provide a succinct answer. 2.88. What is the ratio of the Exports(as % of merchandise exports) of 1964 in Singapore to that in Spain?
Offer a very short reply. 3.66. What is the ratio of the Exports(as % of merchandise exports) in 1965 in Singapore to that in Spain?
Keep it short and to the point. 5.06. What is the difference between the highest and the second highest Exports(as % of merchandise exports) of 1962?
Offer a terse response. 11.45. What is the difference between the highest and the second highest Exports(as % of merchandise exports) of 1963?
Your response must be concise. 31.77. What is the difference between the highest and the second highest Exports(as % of merchandise exports) of 1964?
Provide a short and direct response. 22.67. What is the difference between the highest and the second highest Exports(as % of merchandise exports) in 1965?
Provide a short and direct response. 13.88. What is the difference between the highest and the lowest Exports(as % of merchandise exports) of 1962?
Provide a short and direct response. 34.65. What is the difference between the highest and the lowest Exports(as % of merchandise exports) of 1963?
Make the answer very short. 48.22. What is the difference between the highest and the lowest Exports(as % of merchandise exports) of 1964?
Your answer should be very brief. 40.41. What is the difference between the highest and the lowest Exports(as % of merchandise exports) of 1965?
Make the answer very short. 33.06. 